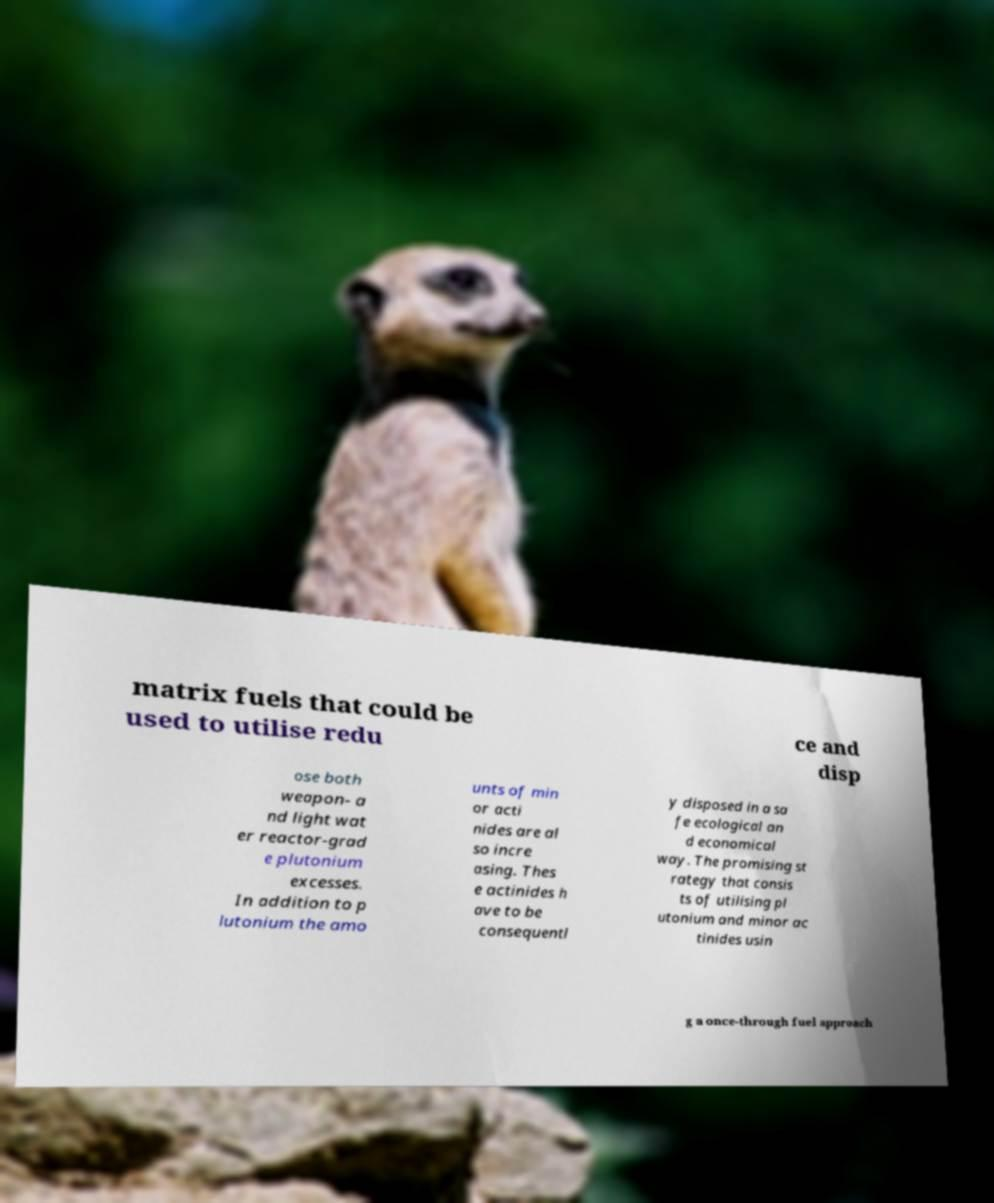What messages or text are displayed in this image? I need them in a readable, typed format. matrix fuels that could be used to utilise redu ce and disp ose both weapon- a nd light wat er reactor-grad e plutonium excesses. In addition to p lutonium the amo unts of min or acti nides are al so incre asing. Thes e actinides h ave to be consequentl y disposed in a sa fe ecological an d economical way. The promising st rategy that consis ts of utilising pl utonium and minor ac tinides usin g a once-through fuel approach 